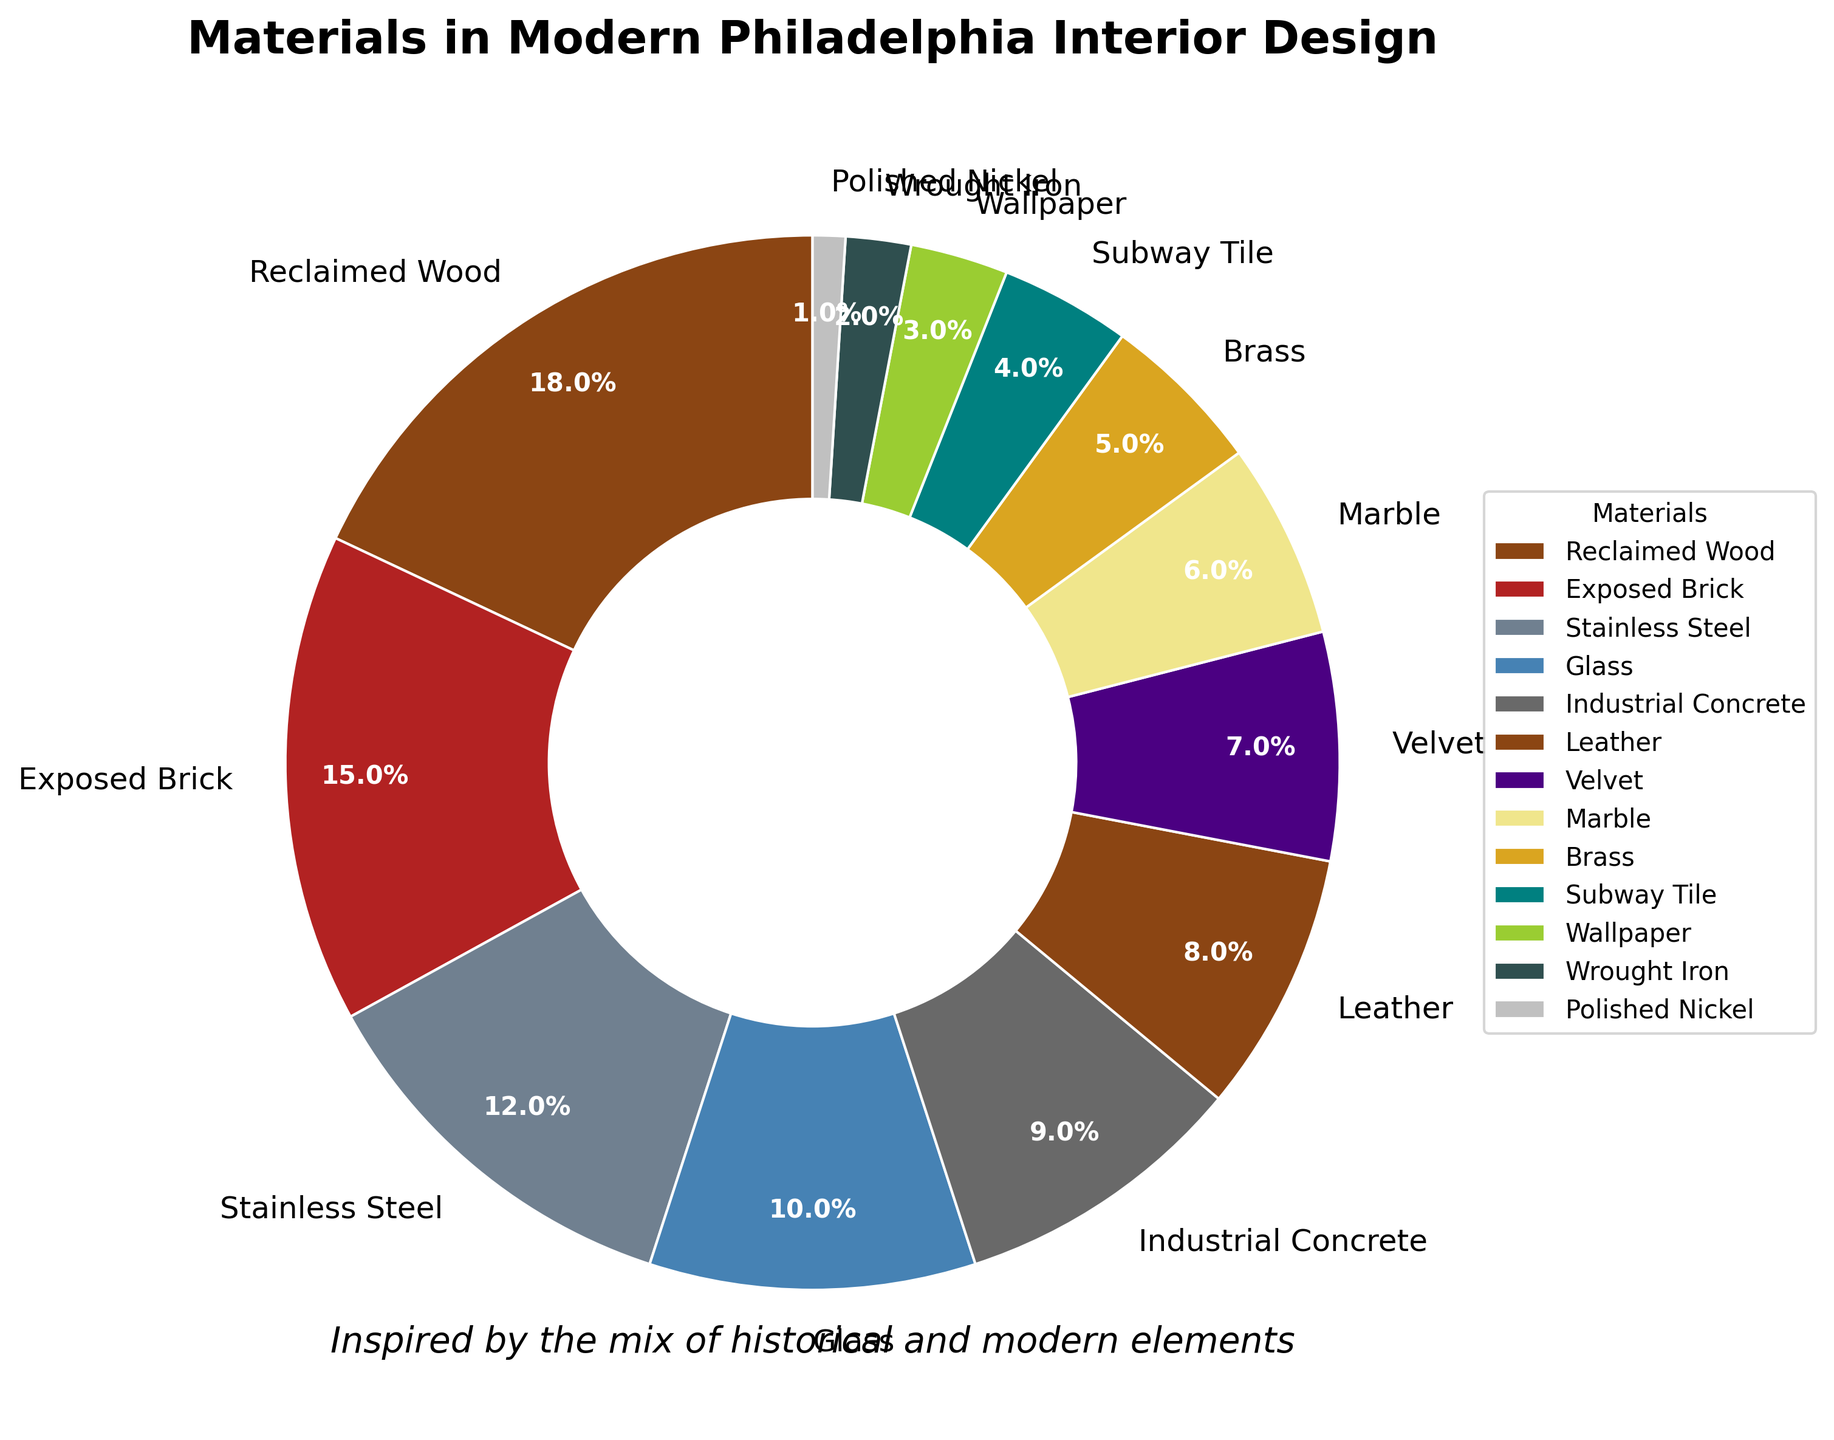What material has the highest proportion in Philadelphia's modern interior design? The largest portion of the pie chart is marked as "Reclaimed Wood" with 18%, making it the highest proportion used.
Answer: Reclaimed Wood What is the combined percentage of Exposed Brick and Stainless Steel? Exposed Brick is 15% and Stainless Steel is 12%. Summing up these percentages gives 15% + 12% = 27%.
Answer: 27% Which materials together constitute less than 10% of the total? By quickly scanning the pie chart for materials with portions under 10%: Subway Tile (4%), Wallpaper (3%), Wrought Iron (2%), and Polished Nickel (1%). Adding these, 4% + 3% + 2% + 1% = 10%.
Answer: Subway Tile, Wallpaper, Wrought Iron, Polished Nickel Is the proportion of Velvet higher than that of Leather? Velvet has 7% and Leather has 8%. Since 8% > 7%, Leather has a higher proportion than Velvet.
Answer: No What are the proportions of the historically inspired materials (Reclaimed Wood, Exposed Brick, Industrial Concrete, Brass, Wrought Iron)? Adding the percentages: Reclaimed Wood (18%), Exposed Brick (15%), Industrial Concrete (9%), Brass (5%), Wrought Iron (2%). Summing these: 18% + 15% + 9% + 5% + 2% = 49%.
Answer: 49% What’s the difference in proportion between Glass and Leather? Glass has 10% and Leather has 8%. Calculating the difference, 10% - 8% = 2%.
Answer: 2% Which material is represented by the darkest color in the pie chart? The darkest color in the chart corresponds to Wrought Iron, which is 2% of the materials.
Answer: Wrought Iron Are there more materials used that account for 5% or less than those that are more than 10%? Materials with 5% or less: Brass (5%), Subway Tile (4%), Wallpaper (3%), Wrought Iron (2%), Polished Nickel (1%). Materials with more than 10%: Reclaimed Wood (18%), Exposed Brick (15%), Stainless Steel (12%). There are 5 materials 5% or less, and 3 materials more than 10%.
Answer: Yes What is the average percentage of Marble, Brass, and Subway Tile? Marble is 6%, Brass is 5%, and Subway Tile is 4%. The average is calculated as (6 + 5 + 4) / 3 = 15 / 3 = 5%.
Answer: 5% If you combine the proportions of Velvet and Wallpaper, does it exceed the proportion of Stainless Steel? Velvet is 7% and Wallpaper is 3%. Combined, they make 7% + 3% = 10%. Stainless Steel is 12%. Since 10% < 12%, the combined proportion does not exceed Stainless Steel.
Answer: No 